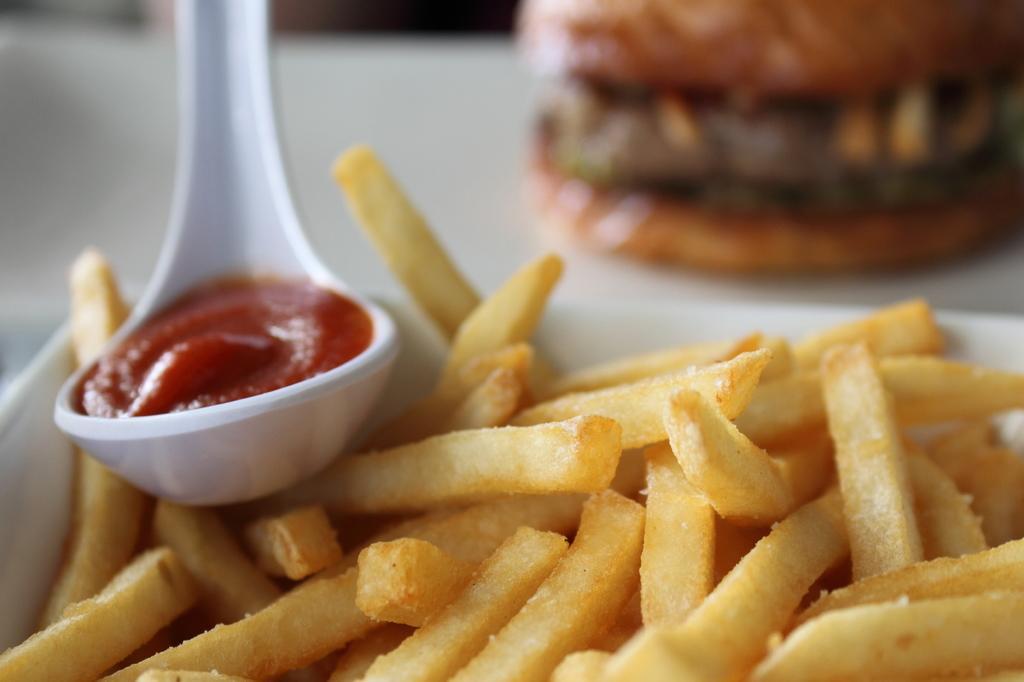Describe this image in one or two sentences. In this image I can see a spoon and food item in a white color object. The background of the image is blurred. 